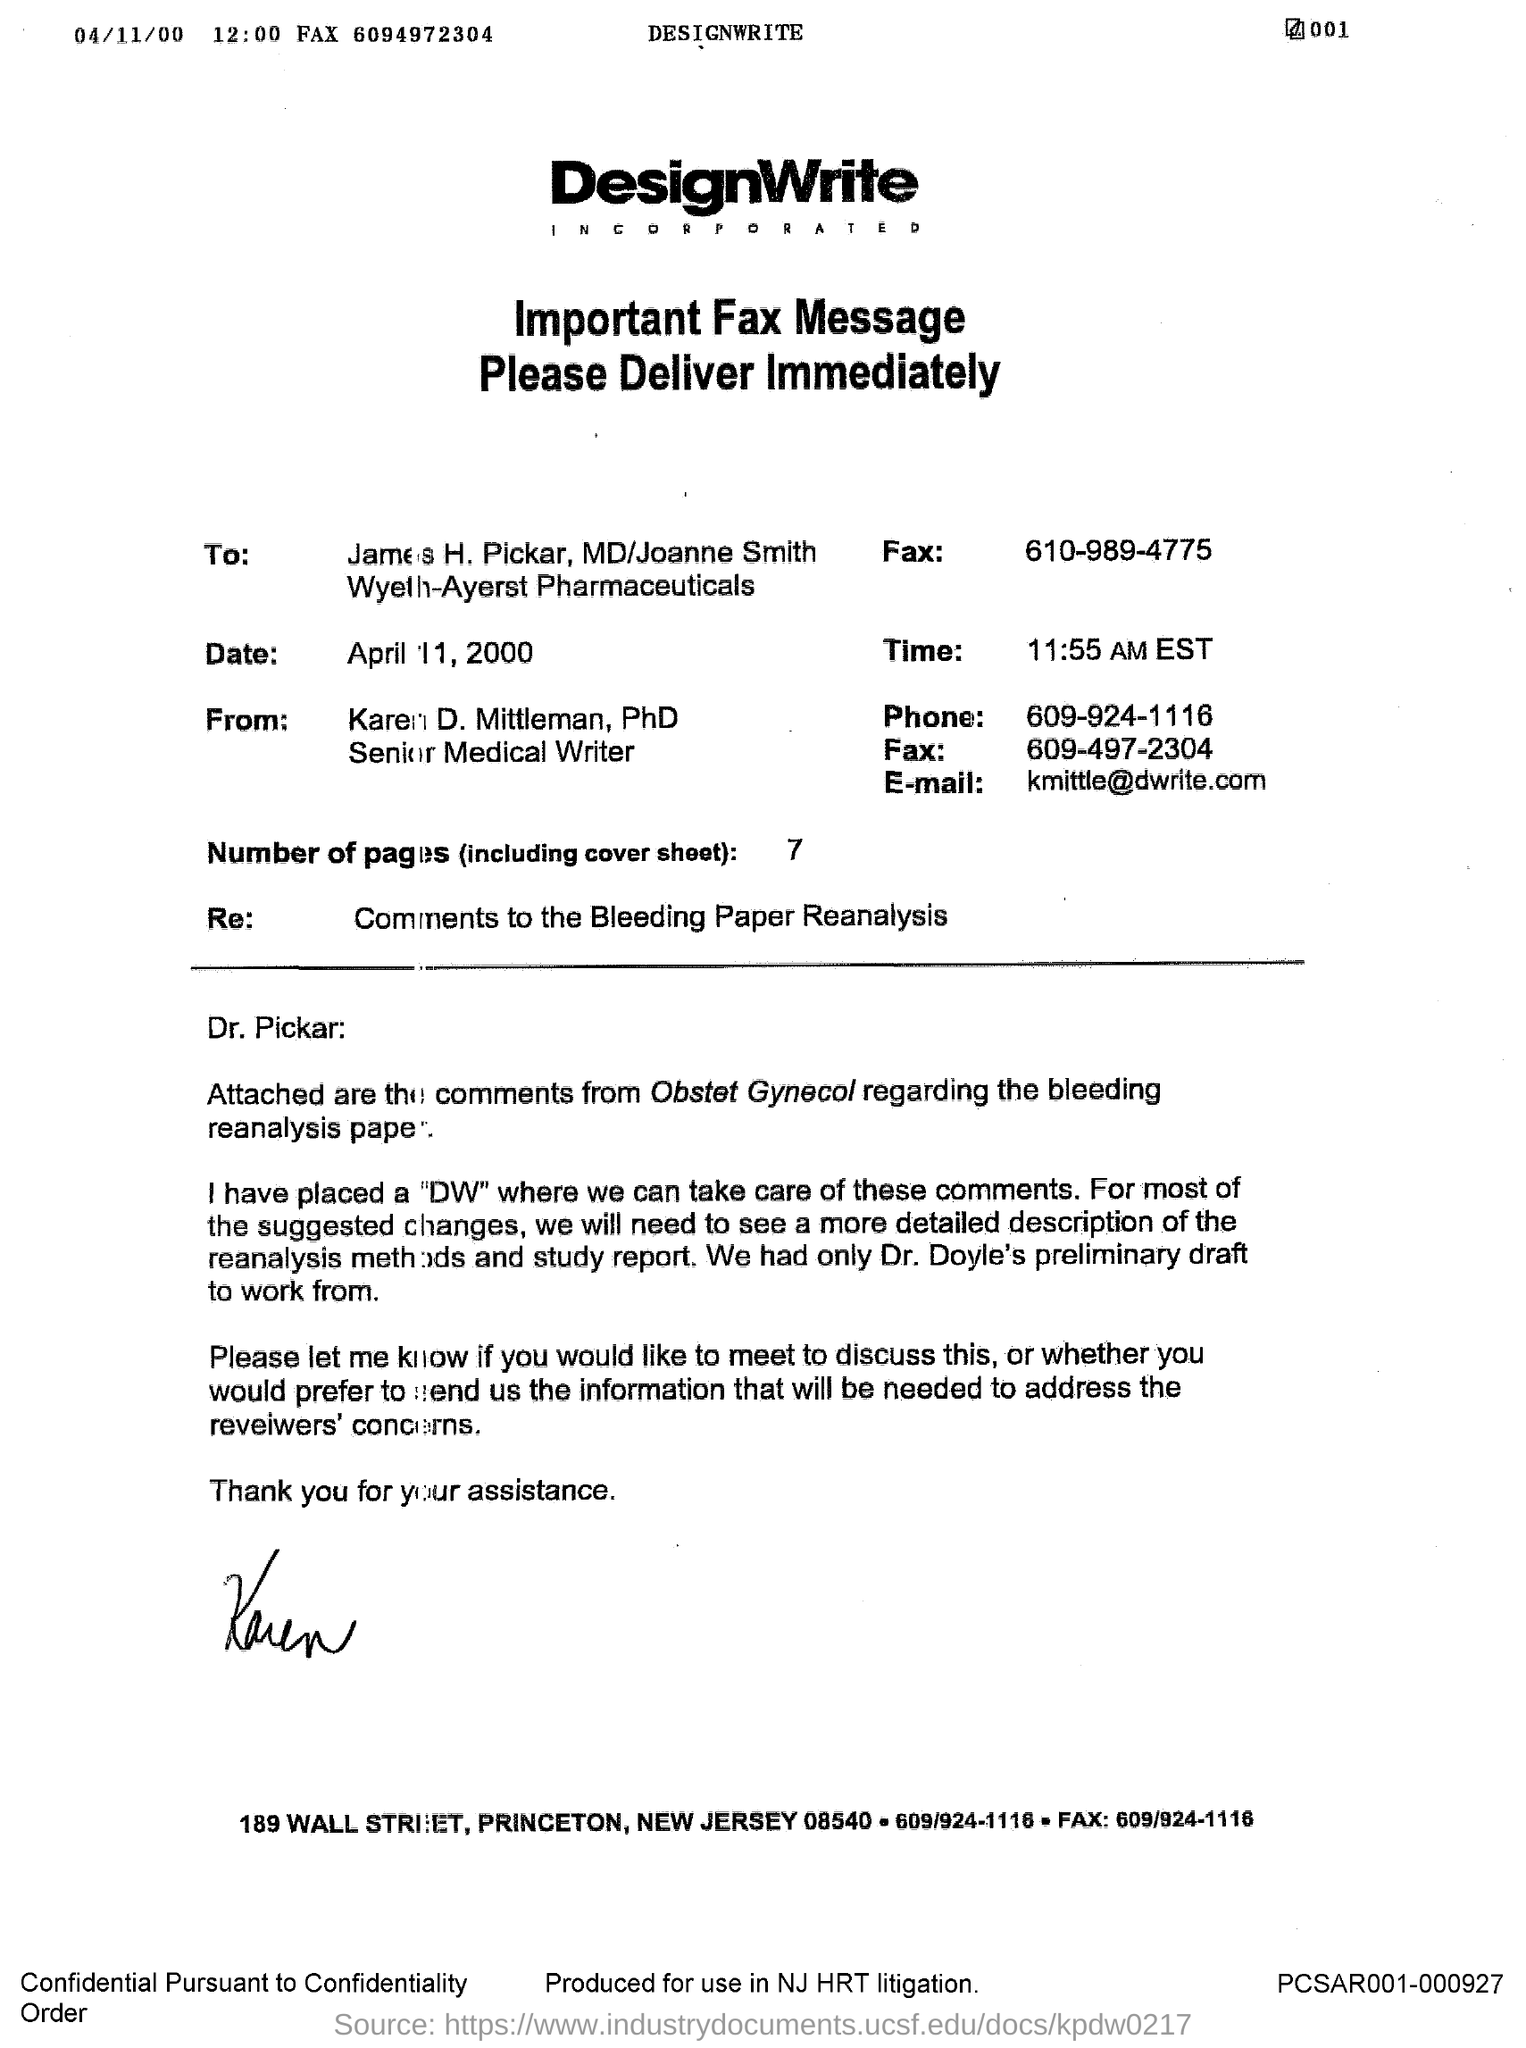Whose draft is available?
Provide a short and direct response. Dr. Doyle. What is time mentioned?
Your answer should be very brief. 11.55 AM EST. 